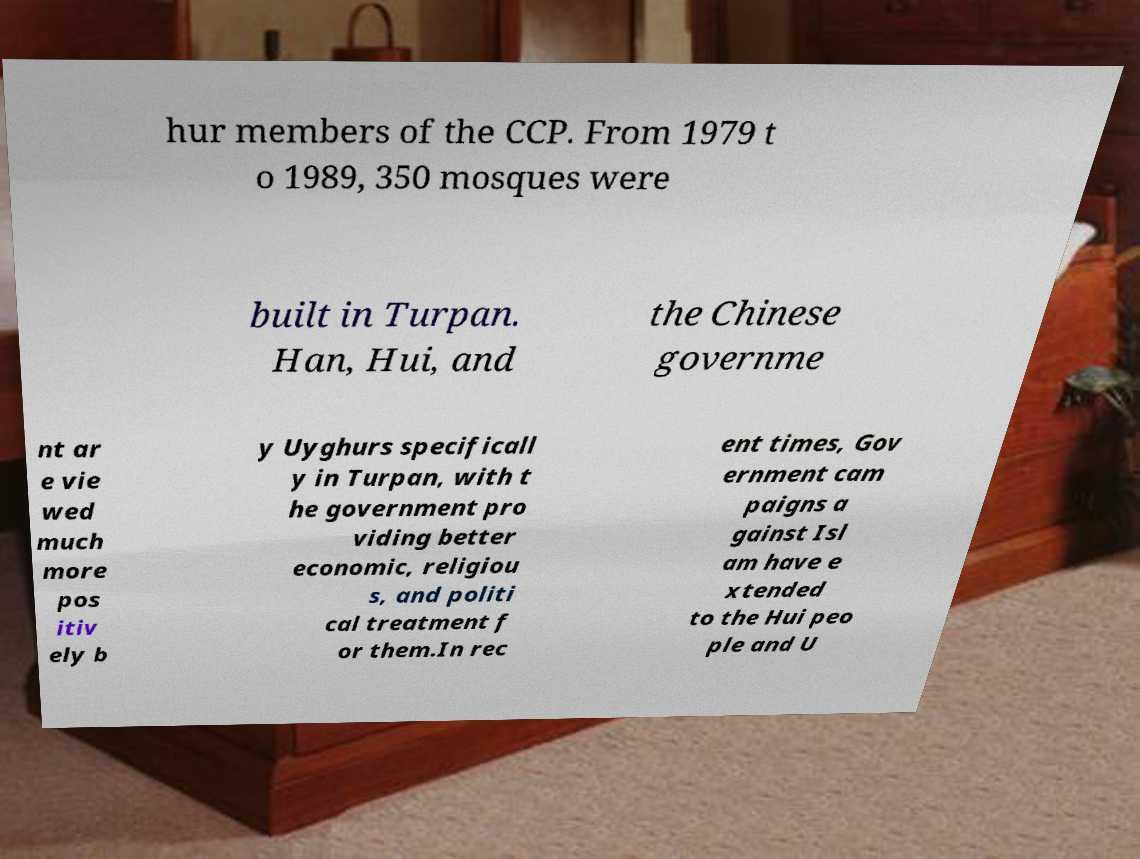Please identify and transcribe the text found in this image. hur members of the CCP. From 1979 t o 1989, 350 mosques were built in Turpan. Han, Hui, and the Chinese governme nt ar e vie wed much more pos itiv ely b y Uyghurs specificall y in Turpan, with t he government pro viding better economic, religiou s, and politi cal treatment f or them.In rec ent times, Gov ernment cam paigns a gainst Isl am have e xtended to the Hui peo ple and U 